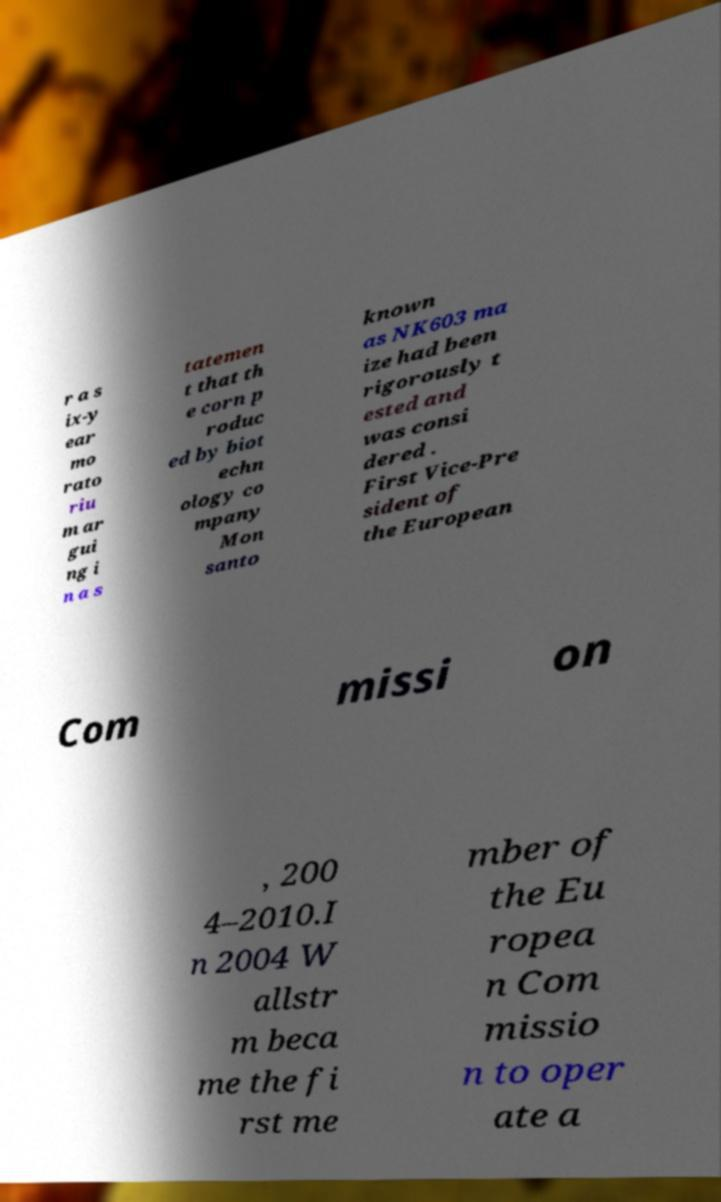Please identify and transcribe the text found in this image. r a s ix-y ear mo rato riu m ar gui ng i n a s tatemen t that th e corn p roduc ed by biot echn ology co mpany Mon santo known as NK603 ma ize had been rigorously t ested and was consi dered . First Vice-Pre sident of the European Com missi on , 200 4–2010.I n 2004 W allstr m beca me the fi rst me mber of the Eu ropea n Com missio n to oper ate a 